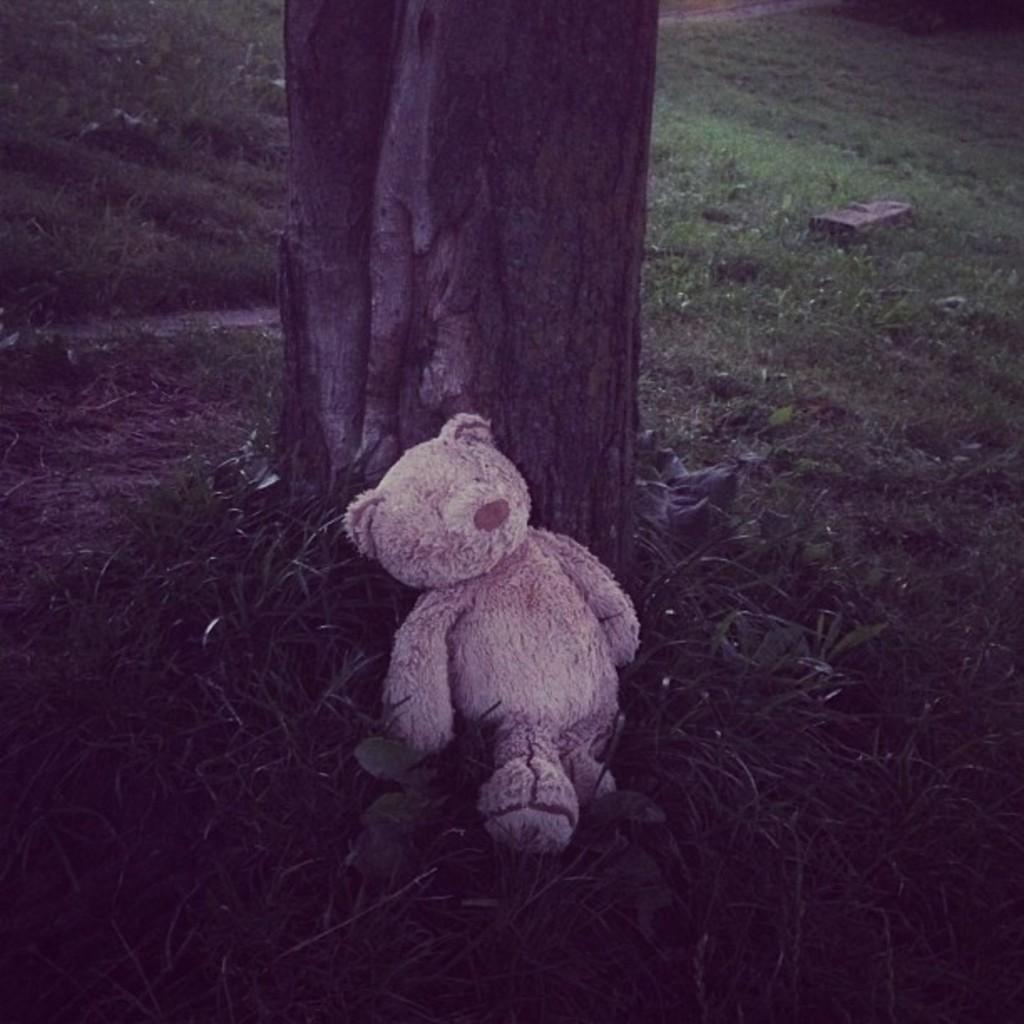Where was the image taken? The image was taken outdoors. What can be seen in the background of the image? There is a ground with grass in the background. What is the main object in the middle of the image? There is a tree in the middle of the image. What is placed on the ground in the image? There is a teddy bear on the ground. What type of health advice is the teddy bear giving in the image? The teddy bear is not giving any health advice in the image, as it is an inanimate object. 